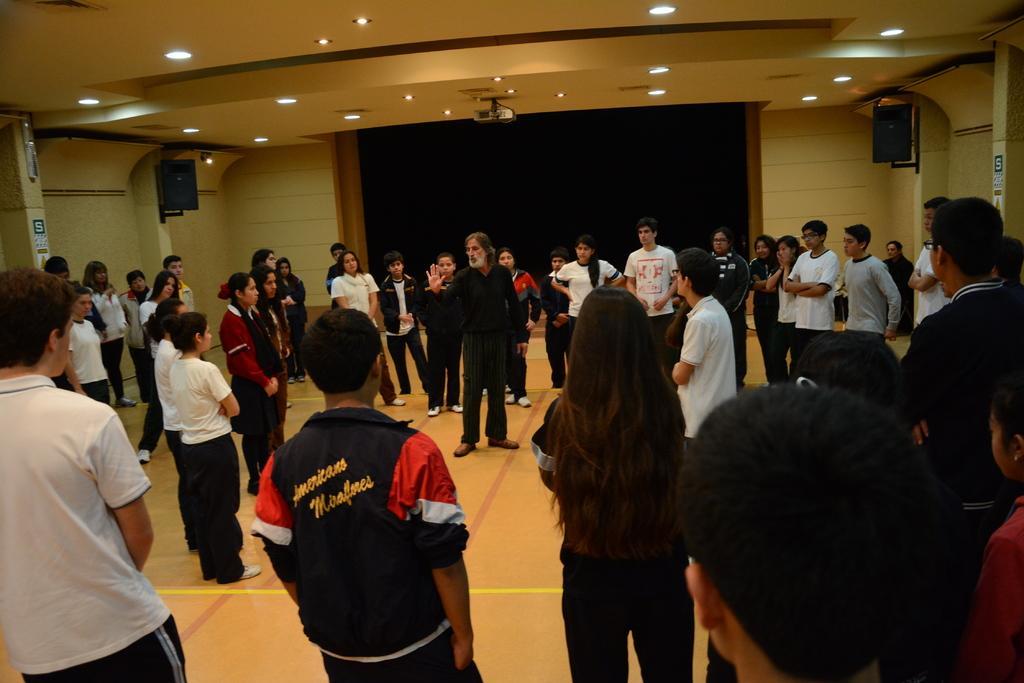How would you summarize this image in a sentence or two? Here we can see group of people on the floor. There are boards, speakers, and lights. In the background we can see a wall. 